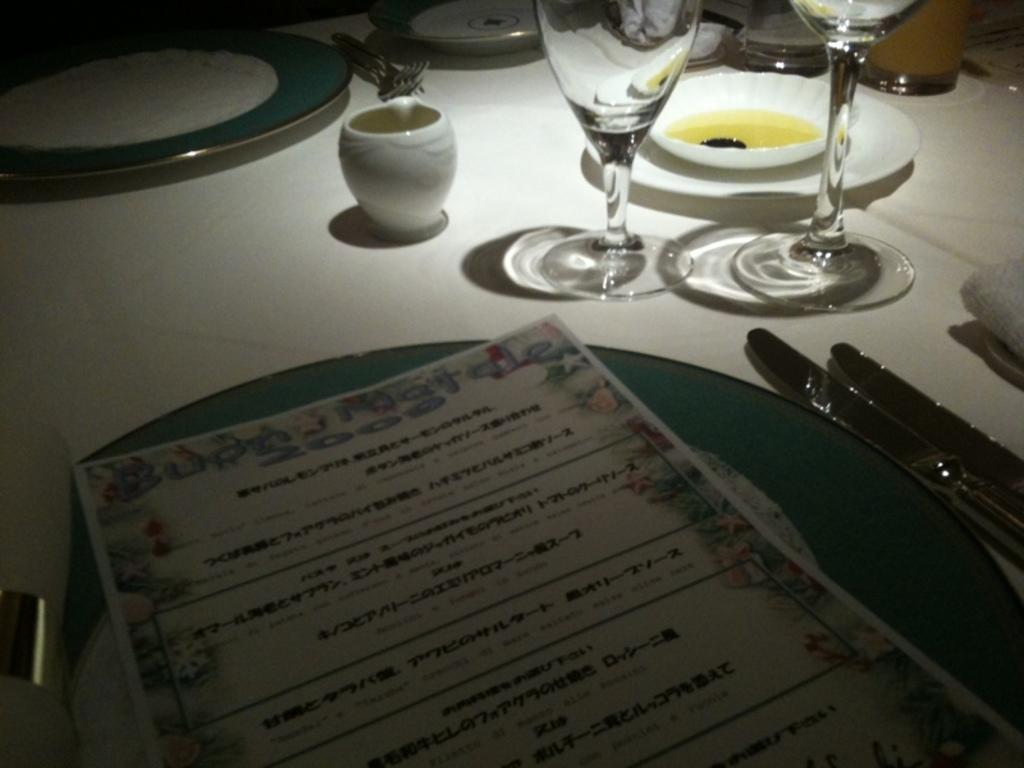What type of tableware can be seen in the image? There are glasses and plates in the image. How many knives are visible in the image? There are two knives in the image. What might be used for selecting food items in the image? There is a menu card in the image. What type of wealth is displayed on the table in the image? There is no indication of wealth in the image; it simply shows glasses, plates, knives, and a menu card. 